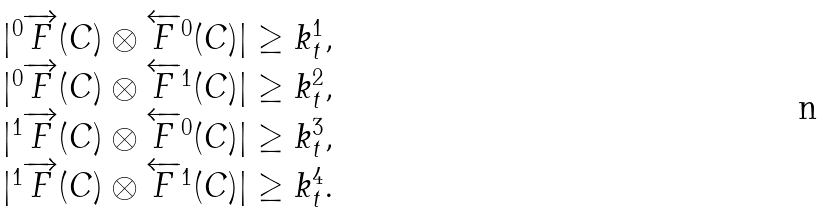<formula> <loc_0><loc_0><loc_500><loc_500>\begin{array} { c } | ^ { 0 } \overrightarrow { F } ( C ) \otimes \overleftarrow { F } ^ { 0 } ( C ) | \geq k _ { t } ^ { 1 } , \\ | ^ { 0 } \overrightarrow { F } ( C ) \otimes \overleftarrow { F } ^ { 1 } ( C ) | \geq k _ { t } ^ { 2 } , \\ | ^ { 1 } \overrightarrow { F } ( C ) \otimes \overleftarrow { F } ^ { 0 } ( C ) | \geq k _ { t } ^ { 3 } , \\ | ^ { 1 } \overrightarrow { F } ( C ) \otimes \overleftarrow { F } ^ { 1 } ( C ) | \geq k _ { t } ^ { 4 } . \\ \end{array}</formula> 